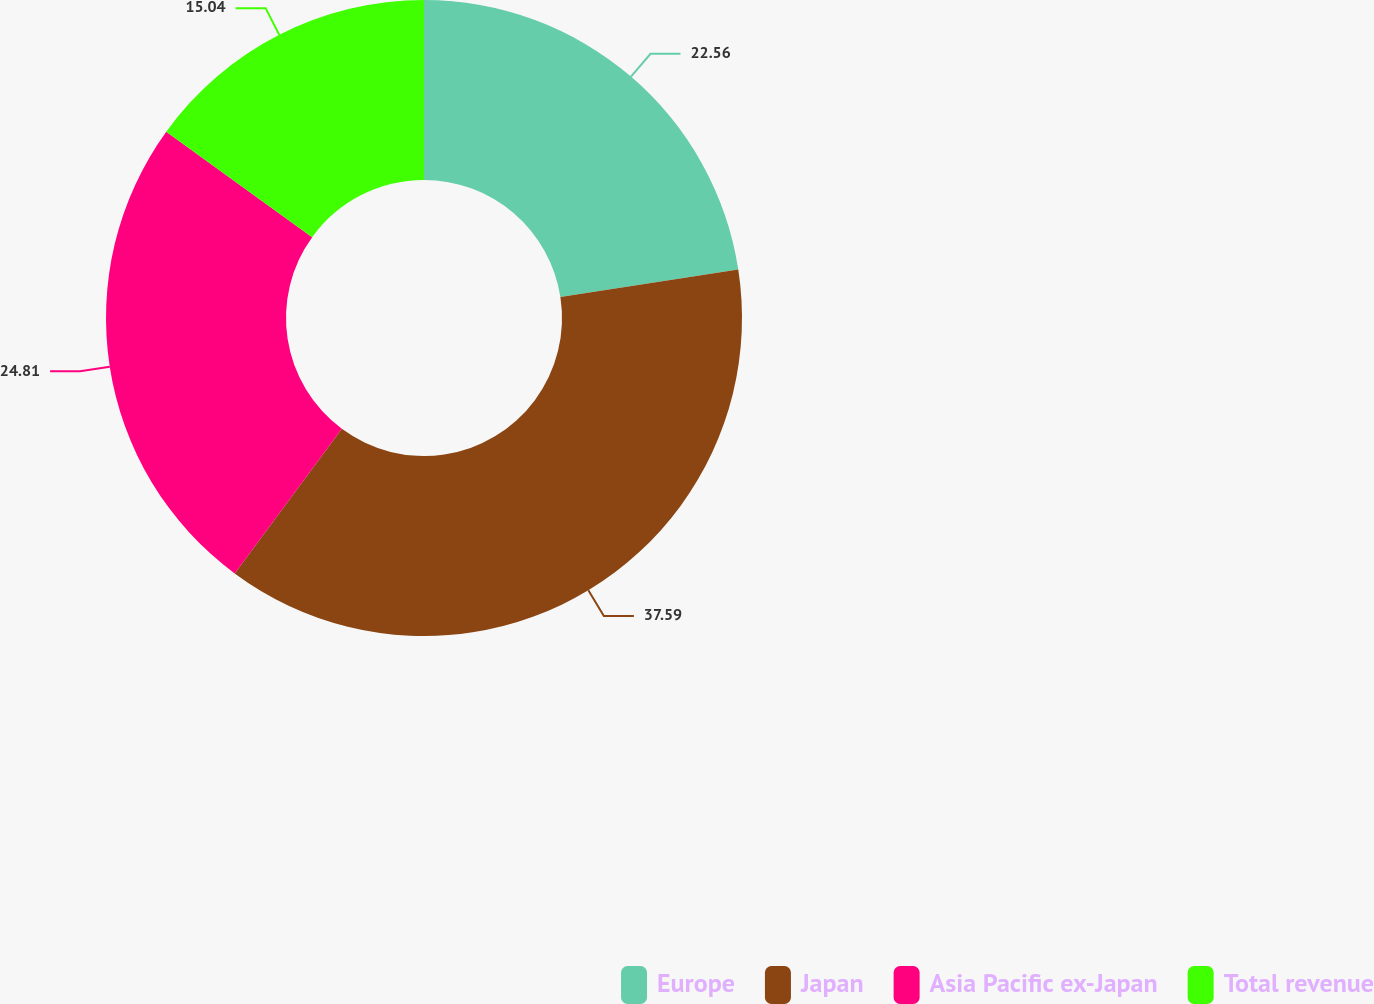Convert chart to OTSL. <chart><loc_0><loc_0><loc_500><loc_500><pie_chart><fcel>Europe<fcel>Japan<fcel>Asia Pacific ex-Japan<fcel>Total revenue<nl><fcel>22.56%<fcel>37.59%<fcel>24.81%<fcel>15.04%<nl></chart> 